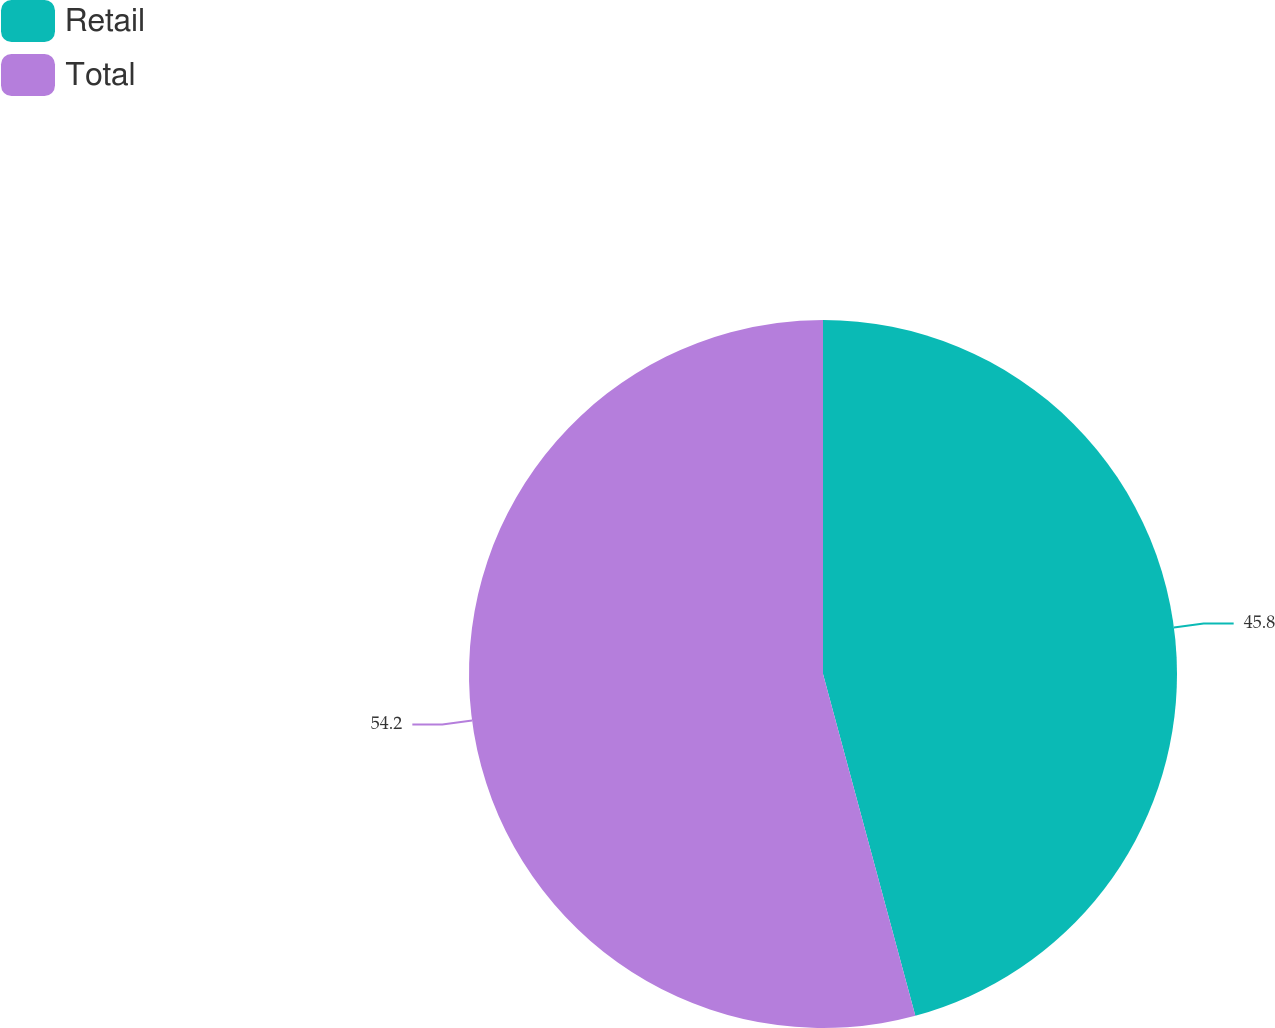Convert chart. <chart><loc_0><loc_0><loc_500><loc_500><pie_chart><fcel>Retail<fcel>Total<nl><fcel>45.8%<fcel>54.2%<nl></chart> 